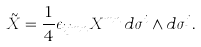<formula> <loc_0><loc_0><loc_500><loc_500>\tilde { X } = \frac { 1 } { 4 } \epsilon _ { i j m n } X ^ { m n } \, d \sigma ^ { i } \wedge d \sigma ^ { j } .</formula> 